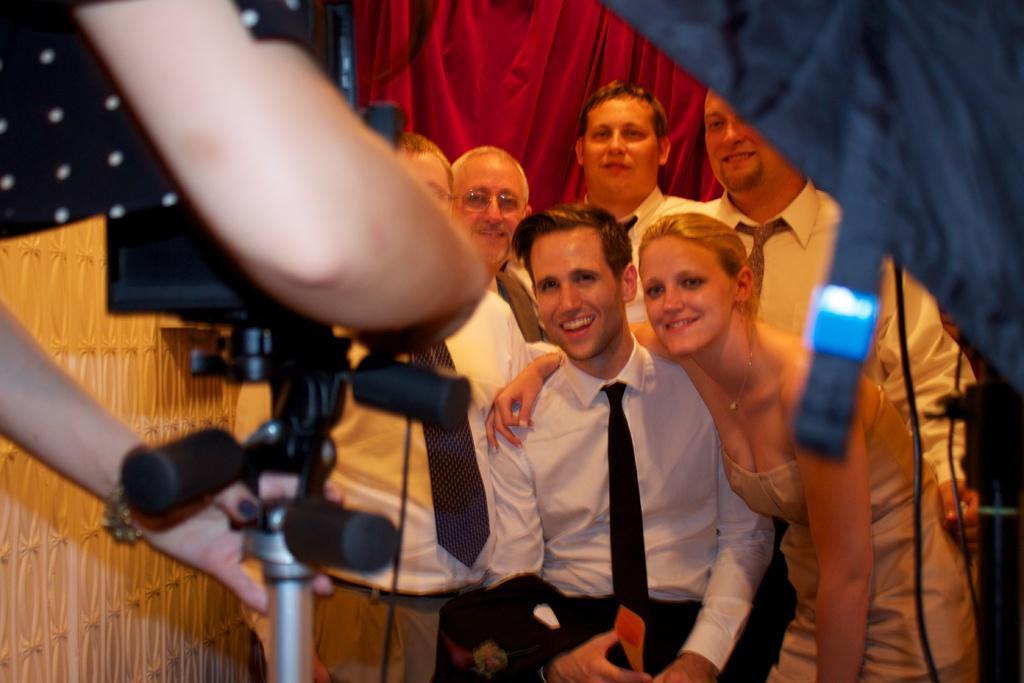Please provide a concise description of this image. In the center of the image some persons are there. On the left side of the image a person is holding a camera, stand. In the background of the image curtain is there. On the left side of the image wall is there. 